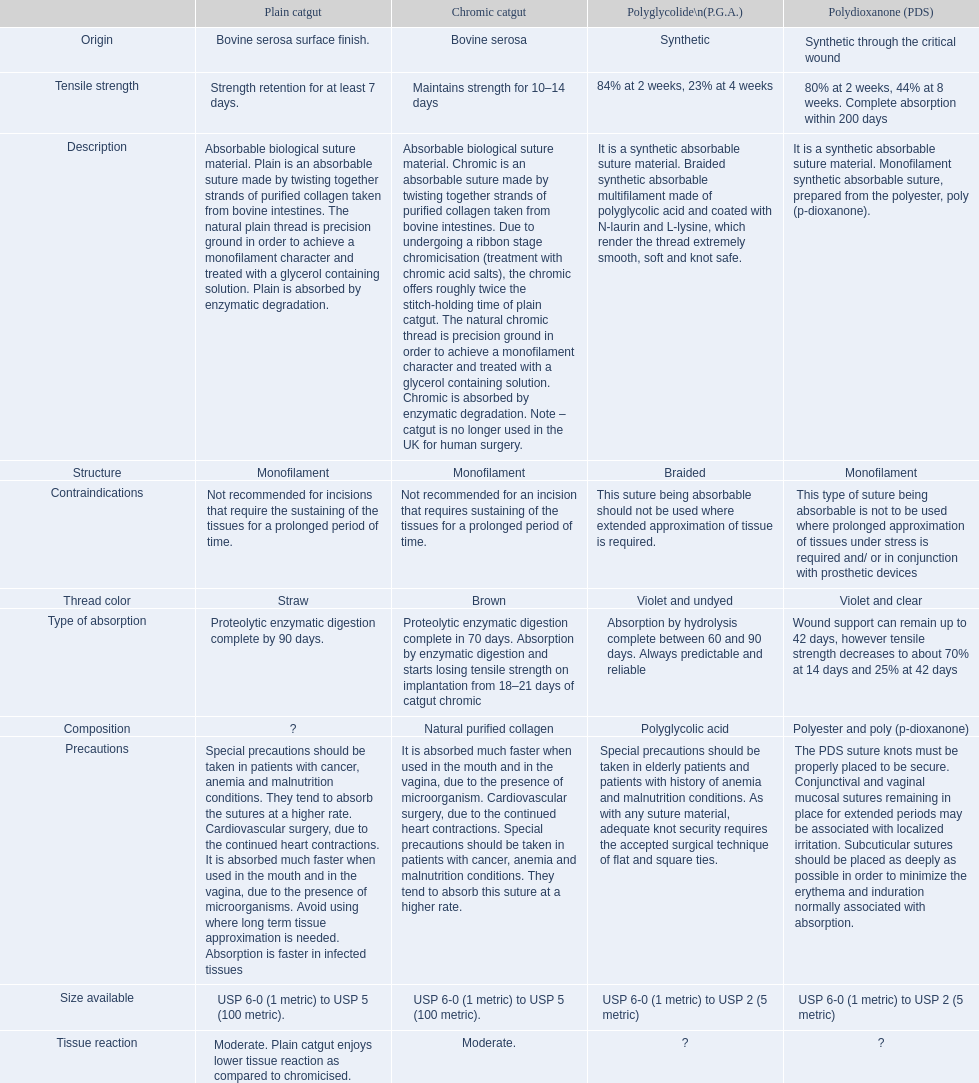How long does a chromic catgut maintain it's strength for 10-14 days. 